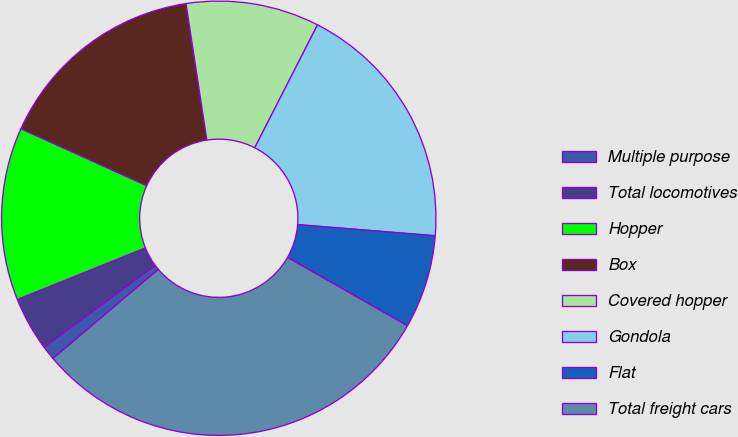Convert chart. <chart><loc_0><loc_0><loc_500><loc_500><pie_chart><fcel>Multiple purpose<fcel>Total locomotives<fcel>Hopper<fcel>Box<fcel>Covered hopper<fcel>Gondola<fcel>Flat<fcel>Total freight cars<nl><fcel>1.06%<fcel>4.01%<fcel>12.87%<fcel>15.82%<fcel>9.92%<fcel>18.77%<fcel>6.96%<fcel>30.58%<nl></chart> 